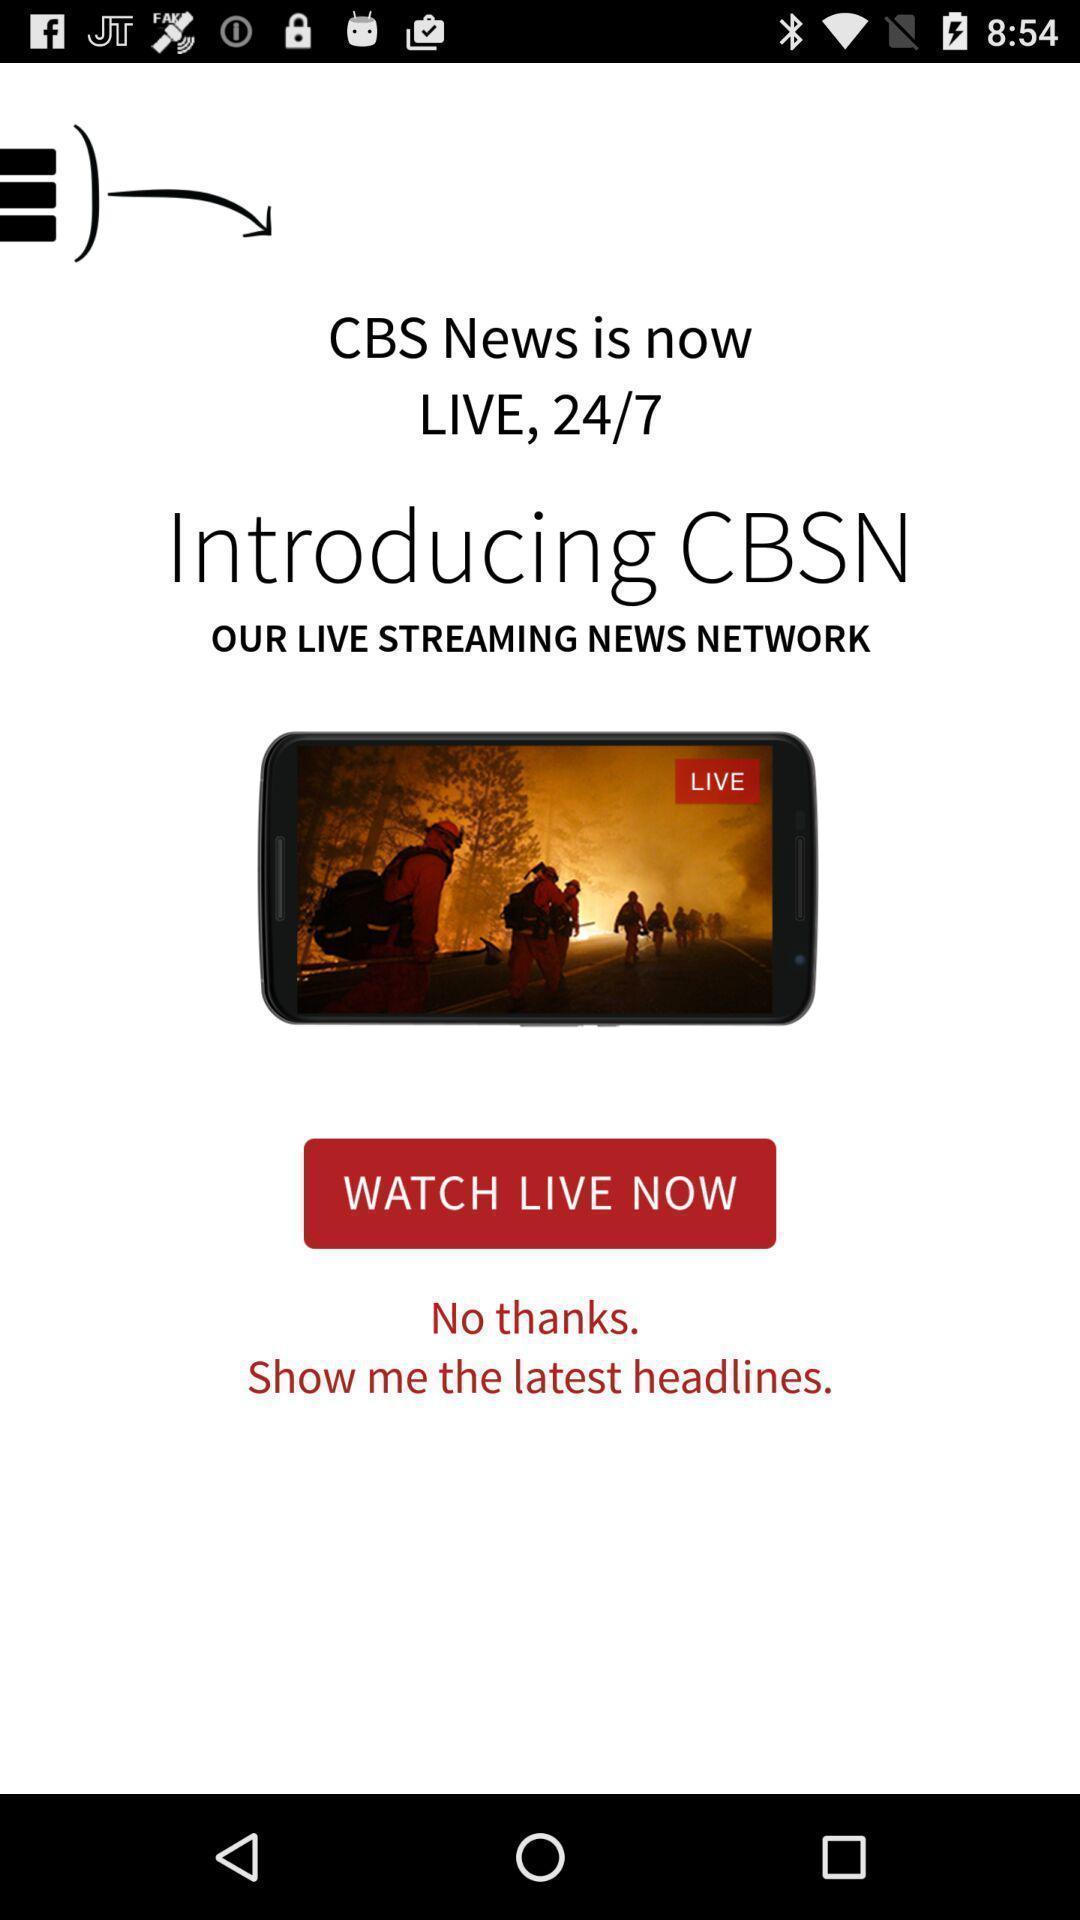What is the overall content of this screenshot? Welcome page for a news streaming app. 